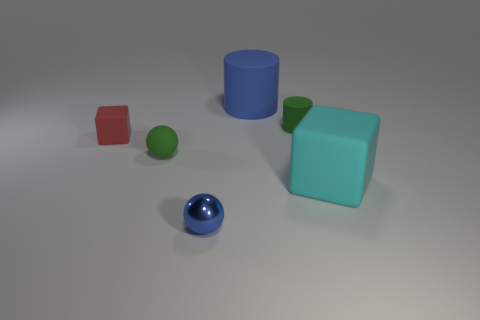Add 2 tiny gray objects. How many objects exist? 8 Subtract all blue cylinders. How many cylinders are left? 1 Subtract all cylinders. How many objects are left? 4 Subtract 2 cylinders. How many cylinders are left? 0 Subtract all red cylinders. Subtract all purple cubes. How many cylinders are left? 2 Subtract all yellow blocks. How many yellow balls are left? 0 Subtract all tiny red rubber cubes. Subtract all matte cylinders. How many objects are left? 3 Add 5 small objects. How many small objects are left? 9 Add 6 big matte cylinders. How many big matte cylinders exist? 7 Subtract 0 yellow cylinders. How many objects are left? 6 